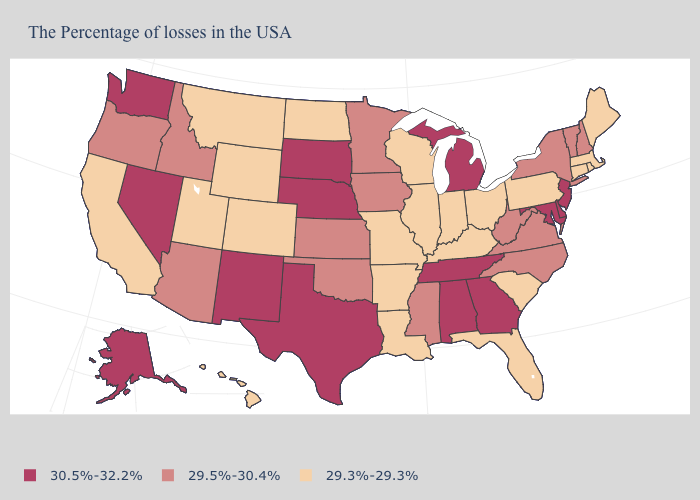Which states have the lowest value in the USA?
Be succinct. Maine, Massachusetts, Rhode Island, Connecticut, Pennsylvania, South Carolina, Ohio, Florida, Kentucky, Indiana, Wisconsin, Illinois, Louisiana, Missouri, Arkansas, North Dakota, Wyoming, Colorado, Utah, Montana, California, Hawaii. What is the value of Wisconsin?
Short answer required. 29.3%-29.3%. Is the legend a continuous bar?
Short answer required. No. Which states have the lowest value in the MidWest?
Answer briefly. Ohio, Indiana, Wisconsin, Illinois, Missouri, North Dakota. What is the value of Hawaii?
Quick response, please. 29.3%-29.3%. What is the lowest value in the USA?
Concise answer only. 29.3%-29.3%. What is the value of South Dakota?
Keep it brief. 30.5%-32.2%. What is the value of Oregon?
Give a very brief answer. 29.5%-30.4%. Does Ohio have the highest value in the USA?
Write a very short answer. No. Name the states that have a value in the range 29.3%-29.3%?
Keep it brief. Maine, Massachusetts, Rhode Island, Connecticut, Pennsylvania, South Carolina, Ohio, Florida, Kentucky, Indiana, Wisconsin, Illinois, Louisiana, Missouri, Arkansas, North Dakota, Wyoming, Colorado, Utah, Montana, California, Hawaii. Does Wisconsin have the same value as Washington?
Give a very brief answer. No. Does Tennessee have the highest value in the South?
Concise answer only. Yes. Which states hav the highest value in the West?
Give a very brief answer. New Mexico, Nevada, Washington, Alaska. Is the legend a continuous bar?
Quick response, please. No. Among the states that border Colorado , which have the lowest value?
Quick response, please. Wyoming, Utah. 